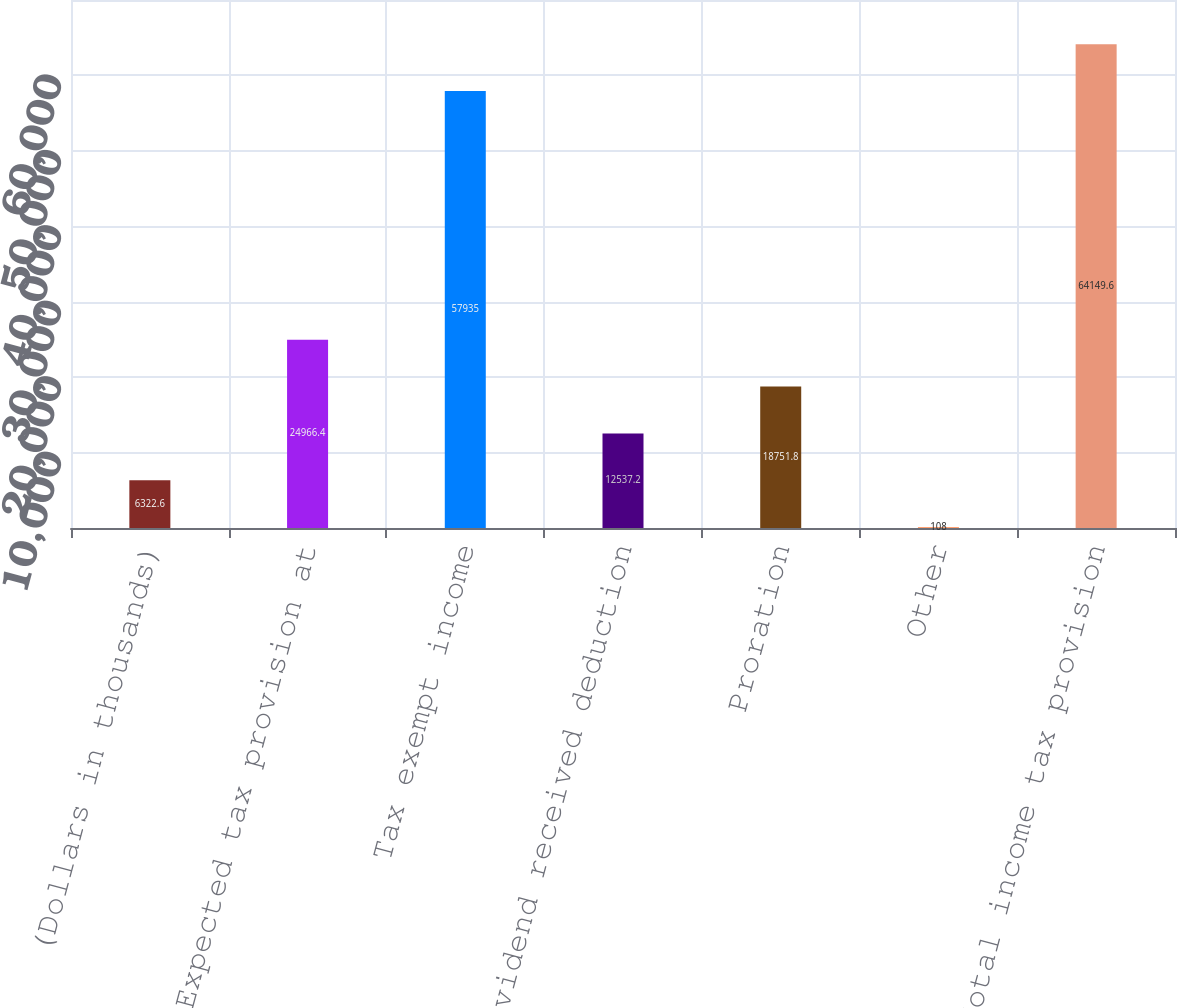Convert chart to OTSL. <chart><loc_0><loc_0><loc_500><loc_500><bar_chart><fcel>(Dollars in thousands)<fcel>Expected tax provision at<fcel>Tax exempt income<fcel>Dividend received deduction<fcel>Proration<fcel>Other<fcel>Total income tax provision<nl><fcel>6322.6<fcel>24966.4<fcel>57935<fcel>12537.2<fcel>18751.8<fcel>108<fcel>64149.6<nl></chart> 